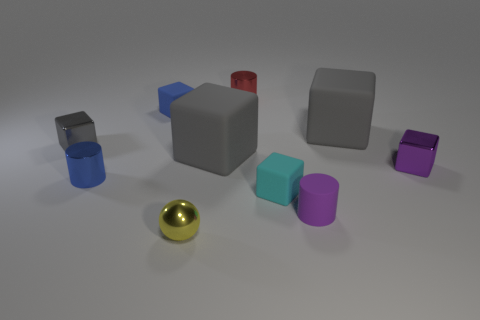What number of things are yellow metallic things that are to the left of the purple rubber object or green objects?
Provide a succinct answer. 1. What color is the shiny sphere that is the same size as the red object?
Give a very brief answer. Yellow. Is the number of rubber things that are left of the yellow thing greater than the number of brown cylinders?
Keep it short and to the point. Yes. There is a cube that is behind the purple shiny object and to the right of the tiny purple cylinder; what material is it?
Your response must be concise. Rubber. Does the metal cube that is on the left side of the small yellow shiny sphere have the same color as the big rubber object that is to the left of the tiny cyan matte thing?
Offer a very short reply. Yes. How many other objects are the same size as the shiny sphere?
Your response must be concise. 7. Are there any gray shiny cubes behind the cylinder that is to the left of the large object on the left side of the tiny cyan thing?
Your answer should be very brief. Yes. Does the cube that is in front of the small purple metallic object have the same material as the small purple cylinder?
Ensure brevity in your answer.  Yes. What is the color of the other matte object that is the same shape as the red thing?
Provide a succinct answer. Purple. Is there any other thing that is the same shape as the yellow shiny object?
Offer a very short reply. No. 